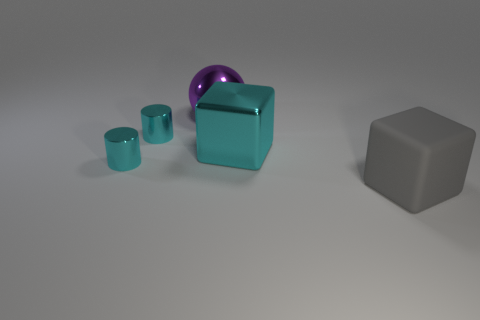What is the shape of the cyan shiny thing that is the same size as the gray block?
Your answer should be very brief. Cube. The sphere has what size?
Offer a very short reply. Large. Do the cube in front of the big metal cube and the cube left of the gray matte thing have the same size?
Your response must be concise. Yes. There is a large metal object that is in front of the large purple thing behind the large cyan block; what is its color?
Offer a very short reply. Cyan. What is the material of the other cube that is the same size as the gray rubber cube?
Offer a very short reply. Metal. What number of rubber objects are either yellow cylinders or blocks?
Make the answer very short. 1. What is the color of the thing that is both in front of the big cyan cube and on the left side of the large cyan object?
Your answer should be very brief. Cyan. How many tiny cyan shiny things are in front of the shiny block?
Make the answer very short. 1. What material is the sphere?
Ensure brevity in your answer.  Metal. There is a large metal object that is in front of the big object to the left of the cyan object on the right side of the purple metal thing; what is its color?
Your answer should be compact. Cyan. 